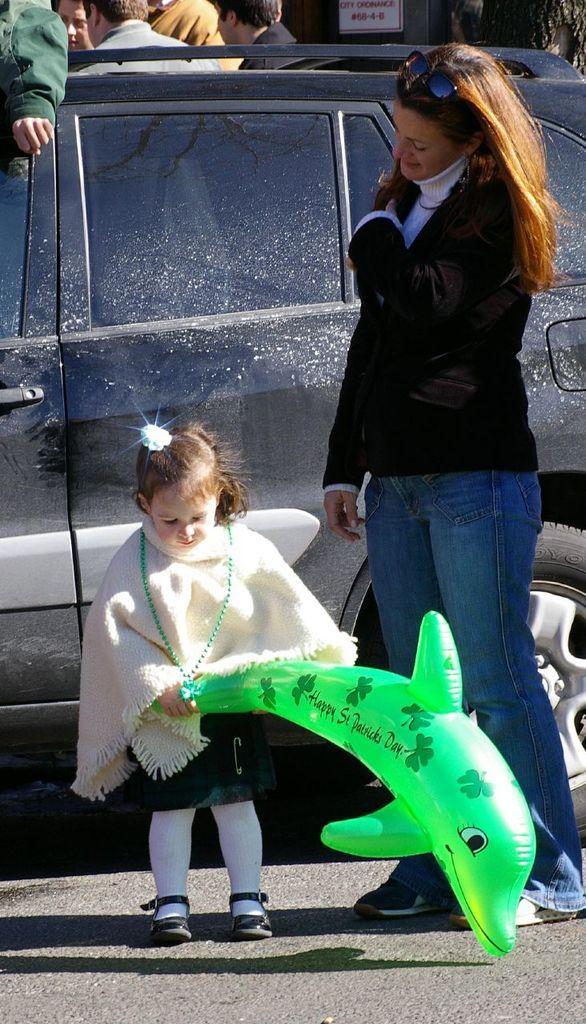Could you give a brief overview of what you see in this image? In this picture we can see a woman and a kid standing here, there is a balloon here, we can see a car and some people in the background, there is a board here. 